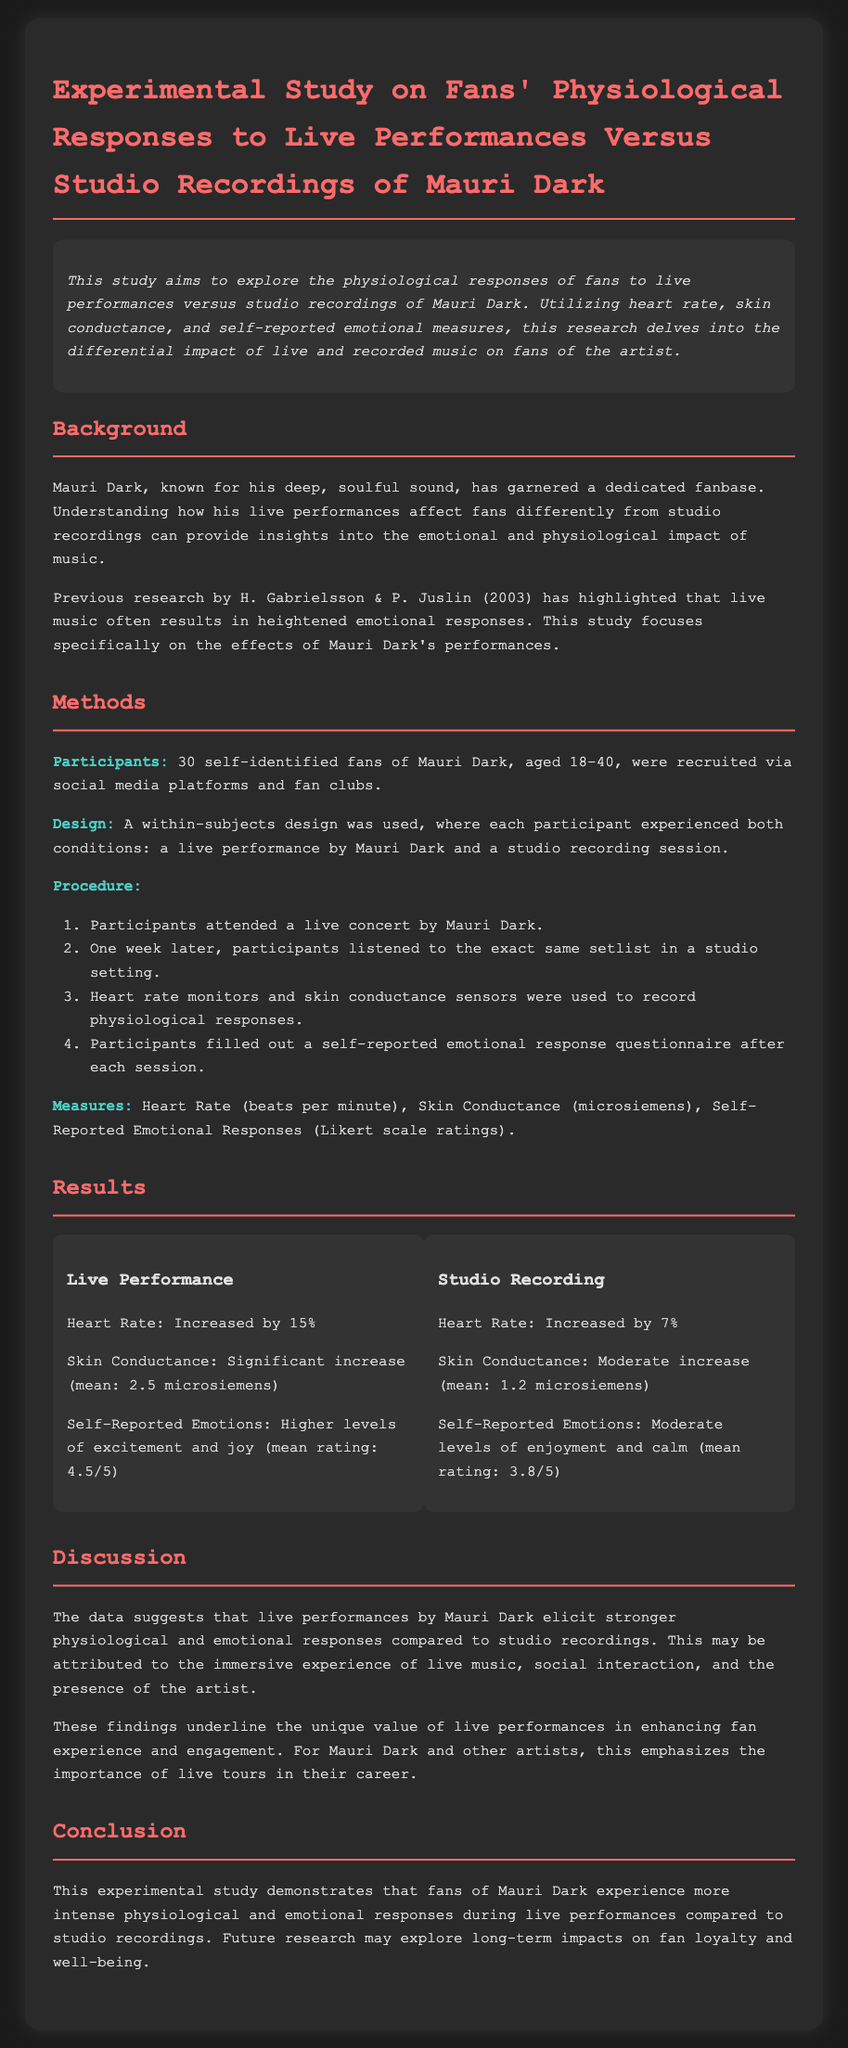What was the sample size of the study? The sample size refers to the number of participants involved in the study, which is specified as 30 self-identified fans.
Answer: 30 What percentage did heart rate increase during live performances? The heart rate increase during live performances is quantified in the results section, which states an increase of 15%.
Answer: 15% What measure was used for self-reported emotional responses? The measure used is detailed in the Methods section, indicating it was based on Likert scale ratings.
Answer: Likert scale ratings How much did skin conductance increase for the studio recording condition? The document specifies the increase in skin conductance for the studio recording, noting a moderate increase with a mean of 1.2 microsiemens.
Answer: 1.2 microsiemens What main emotional responses were reported after live performances? The emotional responses are detailed in the results, highlighting higher levels of excitement and joy with a mean rating of 4.5 out of 5.
Answer: Excitement and joy Why is the immersive experience of live music significant? The significance is discussed in the discussion section, indicating it enhances fan experience and engagement during live performances.
Answer: Enhances fan experience and engagement Who are the researchers cited in the background section? The background section references previous research done by H. Gabrielsson & P. Juslin, which is relevant for understanding emotional responses.
Answer: H. Gabrielsson & P. Juslin What is the mean rating for self-reported emotions after studio recordings? The document provides this information, stating that the mean rating after studio recordings was 3.8 out of 5.
Answer: 3.8 out of 5 